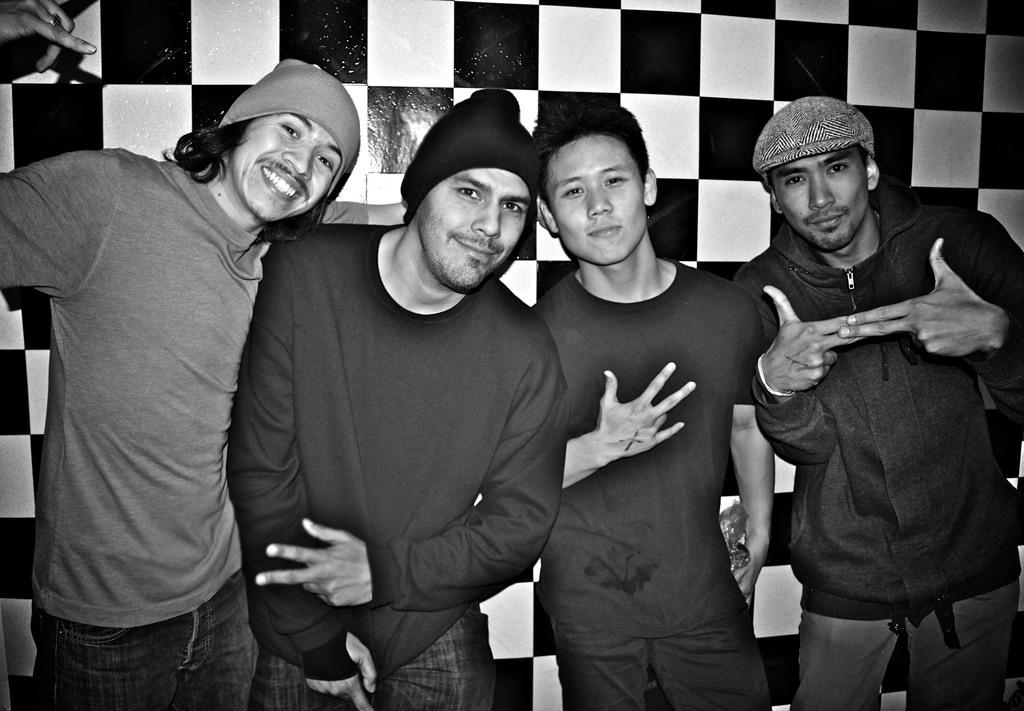What are the people in the image doing? The people in the image are standing near a wall. Can you describe the object being held by one of the people? There is a person holding an object in the image, but the specific object is not mentioned in the provided facts. How does the person holding the object in the image sort the items on the wall? There is no information about sorting or items on the wall in the provided facts, so we cannot answer this question. 